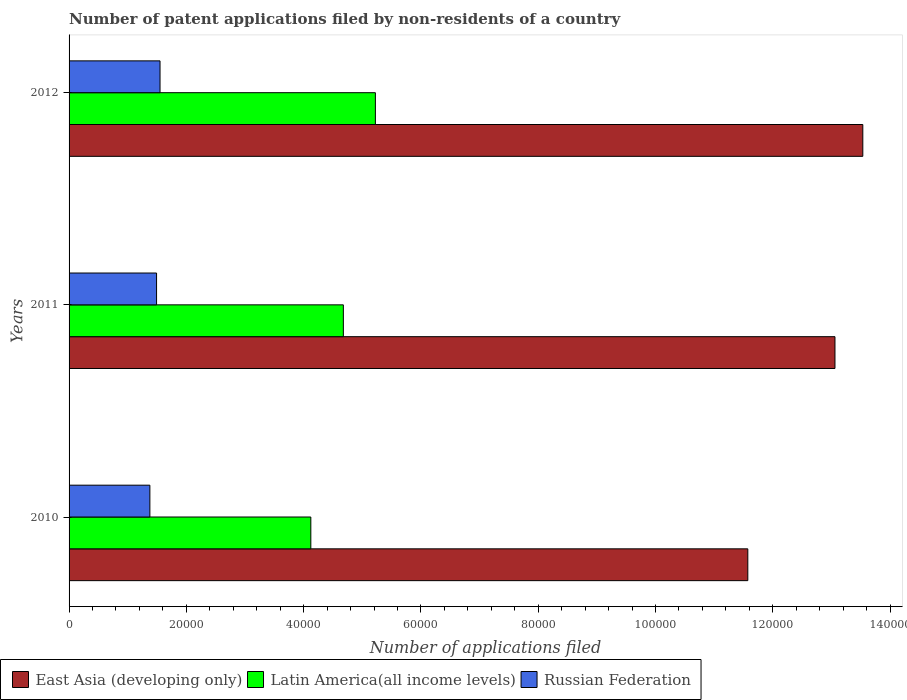How many groups of bars are there?
Ensure brevity in your answer.  3. Are the number of bars on each tick of the Y-axis equal?
Give a very brief answer. Yes. What is the label of the 1st group of bars from the top?
Provide a succinct answer. 2012. What is the number of applications filed in Latin America(all income levels) in 2010?
Make the answer very short. 4.12e+04. Across all years, what is the maximum number of applications filed in Latin America(all income levels)?
Provide a succinct answer. 5.22e+04. Across all years, what is the minimum number of applications filed in Latin America(all income levels)?
Give a very brief answer. 4.12e+04. What is the total number of applications filed in Russian Federation in the graph?
Ensure brevity in your answer.  4.42e+04. What is the difference between the number of applications filed in Russian Federation in 2010 and that in 2011?
Keep it short and to the point. -1141. What is the difference between the number of applications filed in East Asia (developing only) in 2011 and the number of applications filed in Latin America(all income levels) in 2012?
Your answer should be very brief. 7.84e+04. What is the average number of applications filed in Latin America(all income levels) per year?
Your answer should be very brief. 4.67e+04. In the year 2011, what is the difference between the number of applications filed in Latin America(all income levels) and number of applications filed in Russian Federation?
Ensure brevity in your answer.  3.19e+04. In how many years, is the number of applications filed in East Asia (developing only) greater than 88000 ?
Ensure brevity in your answer.  3. What is the ratio of the number of applications filed in East Asia (developing only) in 2010 to that in 2011?
Provide a succinct answer. 0.89. Is the difference between the number of applications filed in Latin America(all income levels) in 2011 and 2012 greater than the difference between the number of applications filed in Russian Federation in 2011 and 2012?
Offer a very short reply. No. What is the difference between the highest and the second highest number of applications filed in Latin America(all income levels)?
Provide a succinct answer. 5462. What is the difference between the highest and the lowest number of applications filed in Latin America(all income levels)?
Offer a terse response. 1.10e+04. Is the sum of the number of applications filed in East Asia (developing only) in 2011 and 2012 greater than the maximum number of applications filed in Latin America(all income levels) across all years?
Keep it short and to the point. Yes. What does the 1st bar from the top in 2010 represents?
Make the answer very short. Russian Federation. What does the 2nd bar from the bottom in 2011 represents?
Your answer should be compact. Latin America(all income levels). Is it the case that in every year, the sum of the number of applications filed in East Asia (developing only) and number of applications filed in Latin America(all income levels) is greater than the number of applications filed in Russian Federation?
Your answer should be compact. Yes. How many bars are there?
Provide a short and direct response. 9. What is the difference between two consecutive major ticks on the X-axis?
Your answer should be very brief. 2.00e+04. Does the graph contain grids?
Provide a succinct answer. No. How are the legend labels stacked?
Offer a terse response. Horizontal. What is the title of the graph?
Make the answer very short. Number of patent applications filed by non-residents of a country. Does "Macao" appear as one of the legend labels in the graph?
Provide a short and direct response. No. What is the label or title of the X-axis?
Offer a terse response. Number of applications filed. What is the Number of applications filed in East Asia (developing only) in 2010?
Your answer should be very brief. 1.16e+05. What is the Number of applications filed in Latin America(all income levels) in 2010?
Your answer should be very brief. 4.12e+04. What is the Number of applications filed in Russian Federation in 2010?
Give a very brief answer. 1.38e+04. What is the Number of applications filed in East Asia (developing only) in 2011?
Ensure brevity in your answer.  1.31e+05. What is the Number of applications filed of Latin America(all income levels) in 2011?
Your response must be concise. 4.68e+04. What is the Number of applications filed of Russian Federation in 2011?
Offer a very short reply. 1.49e+04. What is the Number of applications filed in East Asia (developing only) in 2012?
Your response must be concise. 1.35e+05. What is the Number of applications filed of Latin America(all income levels) in 2012?
Give a very brief answer. 5.22e+04. What is the Number of applications filed in Russian Federation in 2012?
Your response must be concise. 1.55e+04. Across all years, what is the maximum Number of applications filed of East Asia (developing only)?
Your response must be concise. 1.35e+05. Across all years, what is the maximum Number of applications filed of Latin America(all income levels)?
Your answer should be very brief. 5.22e+04. Across all years, what is the maximum Number of applications filed in Russian Federation?
Your answer should be compact. 1.55e+04. Across all years, what is the minimum Number of applications filed of East Asia (developing only)?
Offer a terse response. 1.16e+05. Across all years, what is the minimum Number of applications filed in Latin America(all income levels)?
Offer a very short reply. 4.12e+04. Across all years, what is the minimum Number of applications filed in Russian Federation?
Provide a short and direct response. 1.38e+04. What is the total Number of applications filed in East Asia (developing only) in the graph?
Your answer should be compact. 3.82e+05. What is the total Number of applications filed in Latin America(all income levels) in the graph?
Keep it short and to the point. 1.40e+05. What is the total Number of applications filed of Russian Federation in the graph?
Provide a succinct answer. 4.42e+04. What is the difference between the Number of applications filed of East Asia (developing only) in 2010 and that in 2011?
Keep it short and to the point. -1.49e+04. What is the difference between the Number of applications filed of Latin America(all income levels) in 2010 and that in 2011?
Your answer should be very brief. -5548. What is the difference between the Number of applications filed in Russian Federation in 2010 and that in 2011?
Your response must be concise. -1141. What is the difference between the Number of applications filed in East Asia (developing only) in 2010 and that in 2012?
Keep it short and to the point. -1.96e+04. What is the difference between the Number of applications filed of Latin America(all income levels) in 2010 and that in 2012?
Provide a succinct answer. -1.10e+04. What is the difference between the Number of applications filed in Russian Federation in 2010 and that in 2012?
Provide a succinct answer. -1732. What is the difference between the Number of applications filed in East Asia (developing only) in 2011 and that in 2012?
Provide a short and direct response. -4746. What is the difference between the Number of applications filed in Latin America(all income levels) in 2011 and that in 2012?
Give a very brief answer. -5462. What is the difference between the Number of applications filed of Russian Federation in 2011 and that in 2012?
Keep it short and to the point. -591. What is the difference between the Number of applications filed in East Asia (developing only) in 2010 and the Number of applications filed in Latin America(all income levels) in 2011?
Your response must be concise. 6.90e+04. What is the difference between the Number of applications filed of East Asia (developing only) in 2010 and the Number of applications filed of Russian Federation in 2011?
Your answer should be very brief. 1.01e+05. What is the difference between the Number of applications filed in Latin America(all income levels) in 2010 and the Number of applications filed in Russian Federation in 2011?
Provide a succinct answer. 2.63e+04. What is the difference between the Number of applications filed in East Asia (developing only) in 2010 and the Number of applications filed in Latin America(all income levels) in 2012?
Provide a succinct answer. 6.35e+04. What is the difference between the Number of applications filed in East Asia (developing only) in 2010 and the Number of applications filed in Russian Federation in 2012?
Provide a succinct answer. 1.00e+05. What is the difference between the Number of applications filed in Latin America(all income levels) in 2010 and the Number of applications filed in Russian Federation in 2012?
Provide a succinct answer. 2.57e+04. What is the difference between the Number of applications filed of East Asia (developing only) in 2011 and the Number of applications filed of Latin America(all income levels) in 2012?
Offer a terse response. 7.84e+04. What is the difference between the Number of applications filed in East Asia (developing only) in 2011 and the Number of applications filed in Russian Federation in 2012?
Your answer should be very brief. 1.15e+05. What is the difference between the Number of applications filed of Latin America(all income levels) in 2011 and the Number of applications filed of Russian Federation in 2012?
Make the answer very short. 3.13e+04. What is the average Number of applications filed of East Asia (developing only) per year?
Offer a very short reply. 1.27e+05. What is the average Number of applications filed of Latin America(all income levels) per year?
Ensure brevity in your answer.  4.67e+04. What is the average Number of applications filed in Russian Federation per year?
Make the answer very short. 1.47e+04. In the year 2010, what is the difference between the Number of applications filed of East Asia (developing only) and Number of applications filed of Latin America(all income levels)?
Provide a short and direct response. 7.45e+04. In the year 2010, what is the difference between the Number of applications filed of East Asia (developing only) and Number of applications filed of Russian Federation?
Give a very brief answer. 1.02e+05. In the year 2010, what is the difference between the Number of applications filed in Latin America(all income levels) and Number of applications filed in Russian Federation?
Your response must be concise. 2.74e+04. In the year 2011, what is the difference between the Number of applications filed of East Asia (developing only) and Number of applications filed of Latin America(all income levels)?
Provide a succinct answer. 8.38e+04. In the year 2011, what is the difference between the Number of applications filed in East Asia (developing only) and Number of applications filed in Russian Federation?
Your response must be concise. 1.16e+05. In the year 2011, what is the difference between the Number of applications filed in Latin America(all income levels) and Number of applications filed in Russian Federation?
Your answer should be compact. 3.19e+04. In the year 2012, what is the difference between the Number of applications filed in East Asia (developing only) and Number of applications filed in Latin America(all income levels)?
Offer a very short reply. 8.31e+04. In the year 2012, what is the difference between the Number of applications filed of East Asia (developing only) and Number of applications filed of Russian Federation?
Give a very brief answer. 1.20e+05. In the year 2012, what is the difference between the Number of applications filed in Latin America(all income levels) and Number of applications filed in Russian Federation?
Offer a very short reply. 3.67e+04. What is the ratio of the Number of applications filed of East Asia (developing only) in 2010 to that in 2011?
Your response must be concise. 0.89. What is the ratio of the Number of applications filed of Latin America(all income levels) in 2010 to that in 2011?
Offer a terse response. 0.88. What is the ratio of the Number of applications filed of Russian Federation in 2010 to that in 2011?
Your answer should be compact. 0.92. What is the ratio of the Number of applications filed in East Asia (developing only) in 2010 to that in 2012?
Your response must be concise. 0.86. What is the ratio of the Number of applications filed of Latin America(all income levels) in 2010 to that in 2012?
Your answer should be very brief. 0.79. What is the ratio of the Number of applications filed in Russian Federation in 2010 to that in 2012?
Your answer should be compact. 0.89. What is the ratio of the Number of applications filed of East Asia (developing only) in 2011 to that in 2012?
Provide a short and direct response. 0.96. What is the ratio of the Number of applications filed in Latin America(all income levels) in 2011 to that in 2012?
Provide a succinct answer. 0.9. What is the ratio of the Number of applications filed of Russian Federation in 2011 to that in 2012?
Your response must be concise. 0.96. What is the difference between the highest and the second highest Number of applications filed in East Asia (developing only)?
Make the answer very short. 4746. What is the difference between the highest and the second highest Number of applications filed of Latin America(all income levels)?
Offer a very short reply. 5462. What is the difference between the highest and the second highest Number of applications filed of Russian Federation?
Your answer should be compact. 591. What is the difference between the highest and the lowest Number of applications filed in East Asia (developing only)?
Keep it short and to the point. 1.96e+04. What is the difference between the highest and the lowest Number of applications filed in Latin America(all income levels)?
Ensure brevity in your answer.  1.10e+04. What is the difference between the highest and the lowest Number of applications filed in Russian Federation?
Give a very brief answer. 1732. 